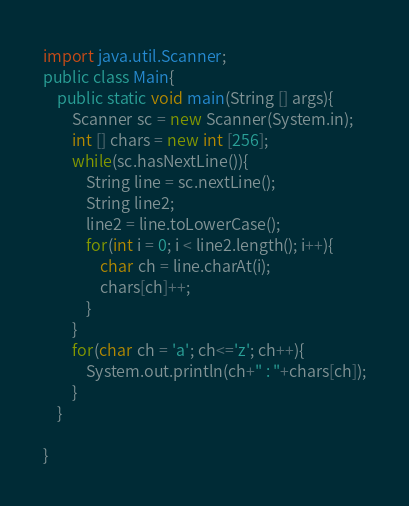Convert code to text. <code><loc_0><loc_0><loc_500><loc_500><_Java_>import java.util.Scanner;
public class Main{
	public static void main(String [] args){
		Scanner sc = new Scanner(System.in);
		int [] chars = new int [256];
		while(sc.hasNextLine()){
			String line = sc.nextLine();
			String line2;
			line2 = line.toLowerCase();
			for(int i = 0; i < line2.length(); i++){
				char ch = line.charAt(i);
				chars[ch]++; 
			}
		}
		for(char ch = 'a'; ch<='z'; ch++){
			System.out.println(ch+" : "+chars[ch]);
		}
	}

}</code> 